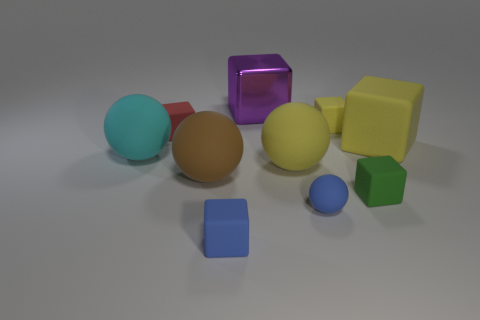Subtract all small red matte cubes. How many cubes are left? 5 Subtract all purple cubes. How many cubes are left? 5 Subtract 1 cubes. How many cubes are left? 5 Subtract all spheres. How many objects are left? 6 Subtract all purple cylinders. How many blue spheres are left? 1 Subtract 1 red cubes. How many objects are left? 9 Subtract all purple balls. Subtract all blue blocks. How many balls are left? 4 Subtract all large blue rubber spheres. Subtract all green things. How many objects are left? 9 Add 3 big brown balls. How many big brown balls are left? 4 Add 4 gray rubber objects. How many gray rubber objects exist? 4 